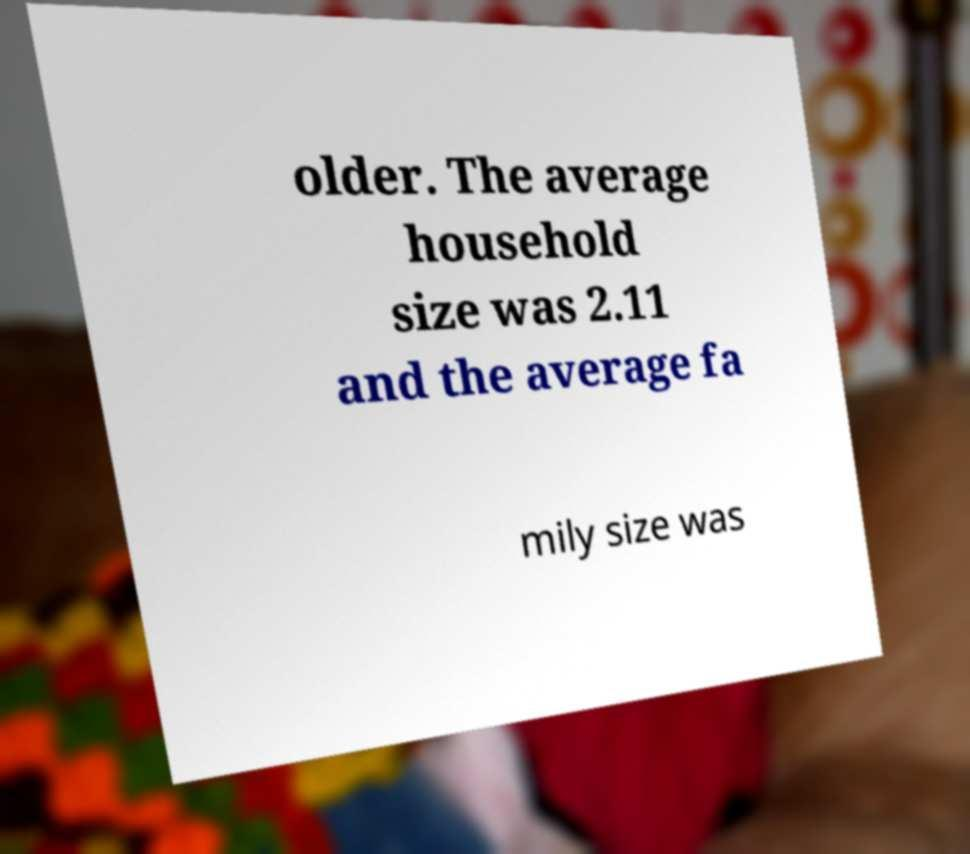There's text embedded in this image that I need extracted. Can you transcribe it verbatim? older. The average household size was 2.11 and the average fa mily size was 